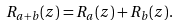Convert formula to latex. <formula><loc_0><loc_0><loc_500><loc_500>R _ { a + b } ( z ) = R _ { a } ( z ) + R _ { b } ( z ) .</formula> 